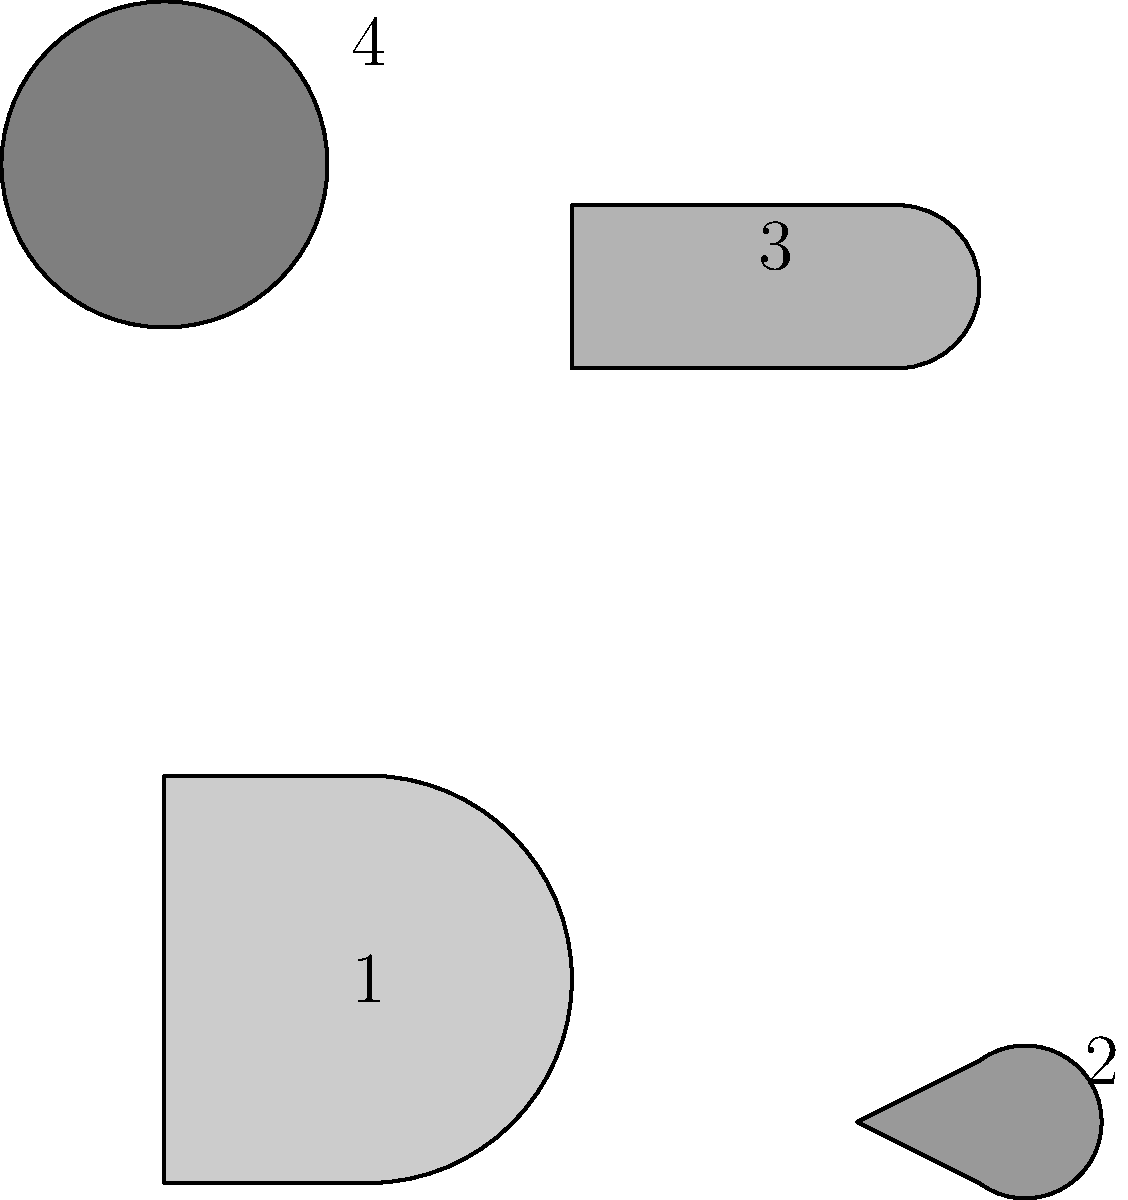Arrange the musical instruments shown in the image to form a square shape. Which instrument should be placed in the top-right corner of the square? To solve this visual puzzle, we need to mentally arrange the musical instruments to form a square shape. Let's follow these steps:

1. Identify the instruments:
   1 - Guitar
   2 - Violin
   3 - Trumpet
   4 - Drum

2. Analyze the shapes:
   - The guitar and trumpet have elongated shapes
   - The violin and drum have more compact shapes

3. Form a square:
   - Place the elongated instruments (guitar and trumpet) on opposite sides
   - Fill the remaining corners with the compact instruments (violin and drum)

4. Arrange the square:
   - Bottom: Guitar (1)
   - Left: Trumpet (3)
   - Top: Drum (4)
   - Right: Violin (2)

5. Identify the top-right corner:
   The instrument in the top-right corner is the violin (2).
Answer: Violin 